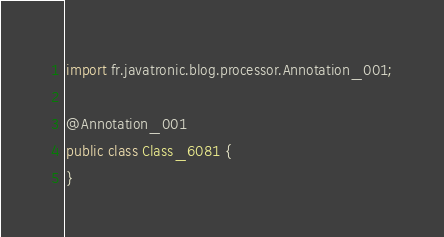Convert code to text. <code><loc_0><loc_0><loc_500><loc_500><_Java_>
import fr.javatronic.blog.processor.Annotation_001;

@Annotation_001
public class Class_6081 {
}
</code> 